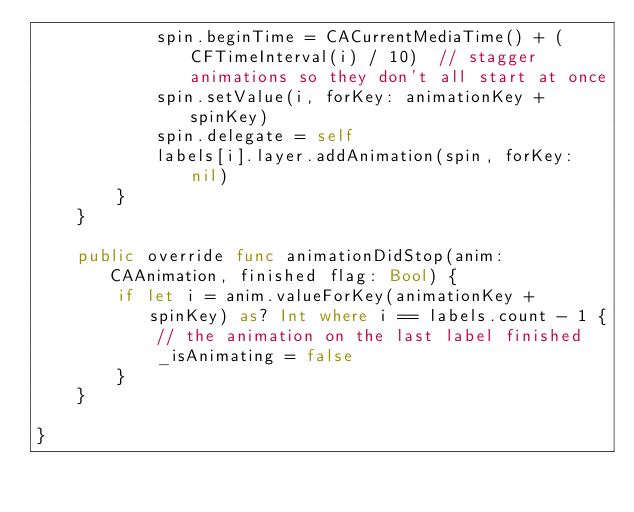<code> <loc_0><loc_0><loc_500><loc_500><_Swift_>            spin.beginTime = CACurrentMediaTime() + (CFTimeInterval(i) / 10)  // stagger animations so they don't all start at once
            spin.setValue(i, forKey: animationKey + spinKey)
            spin.delegate = self
            labels[i].layer.addAnimation(spin, forKey: nil)
        }
    }
    
    public override func animationDidStop(anim: CAAnimation, finished flag: Bool) {
        if let i = anim.valueForKey(animationKey + spinKey) as? Int where i == labels.count - 1 {
            // the animation on the last label finished
            _isAnimating = false
        }
    }
    
}
</code> 